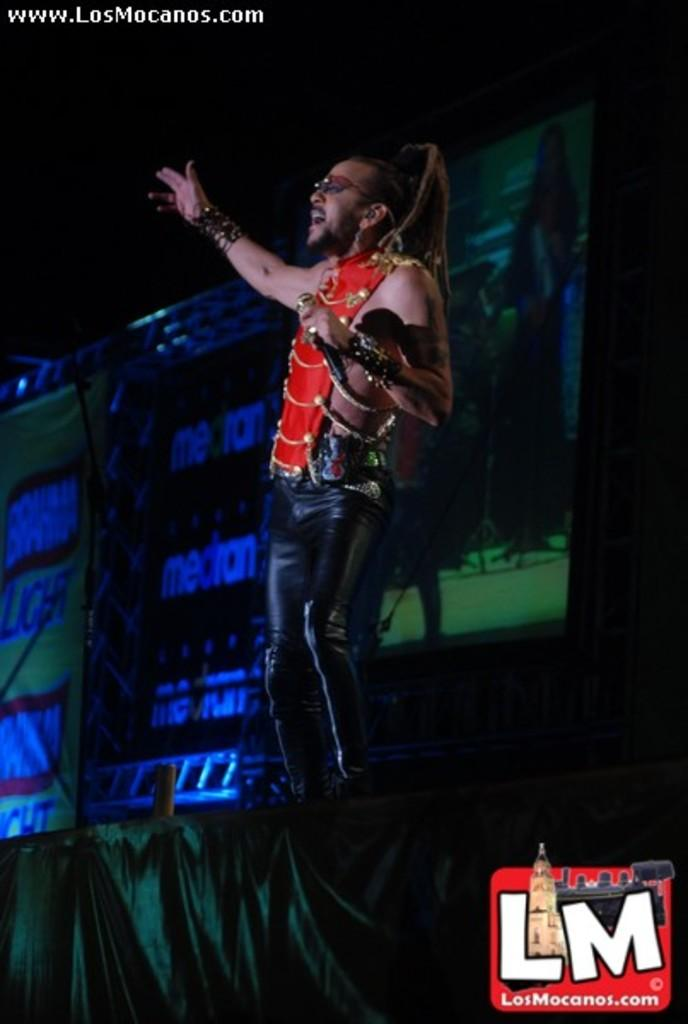What is the person on the stage doing? The person is holding a microphone and singing. What might the person be using the microphone for? The person is likely using the microphone to amplify their voice while singing. What can be seen behind the person on the stage? There is a screen behind the person. How many eyes can be seen on the person's face in the image? The image does not show the person's face, so it is not possible to determine the number of eyes. 